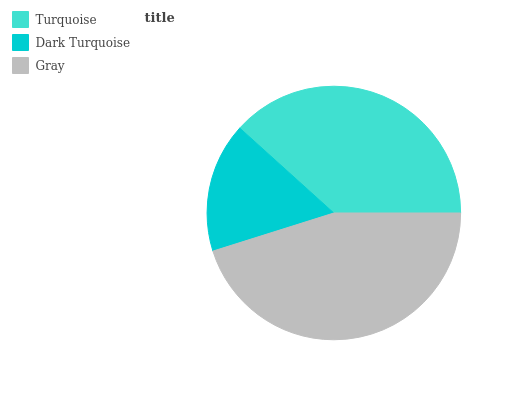Is Dark Turquoise the minimum?
Answer yes or no. Yes. Is Gray the maximum?
Answer yes or no. Yes. Is Gray the minimum?
Answer yes or no. No. Is Dark Turquoise the maximum?
Answer yes or no. No. Is Gray greater than Dark Turquoise?
Answer yes or no. Yes. Is Dark Turquoise less than Gray?
Answer yes or no. Yes. Is Dark Turquoise greater than Gray?
Answer yes or no. No. Is Gray less than Dark Turquoise?
Answer yes or no. No. Is Turquoise the high median?
Answer yes or no. Yes. Is Turquoise the low median?
Answer yes or no. Yes. Is Gray the high median?
Answer yes or no. No. Is Dark Turquoise the low median?
Answer yes or no. No. 